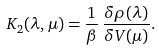Convert formula to latex. <formula><loc_0><loc_0><loc_500><loc_500>K _ { 2 } ( \lambda , \mu ) = \frac { 1 } { \beta } \, \frac { \delta \rho ( \lambda ) } { \delta V ( \mu ) } .</formula> 